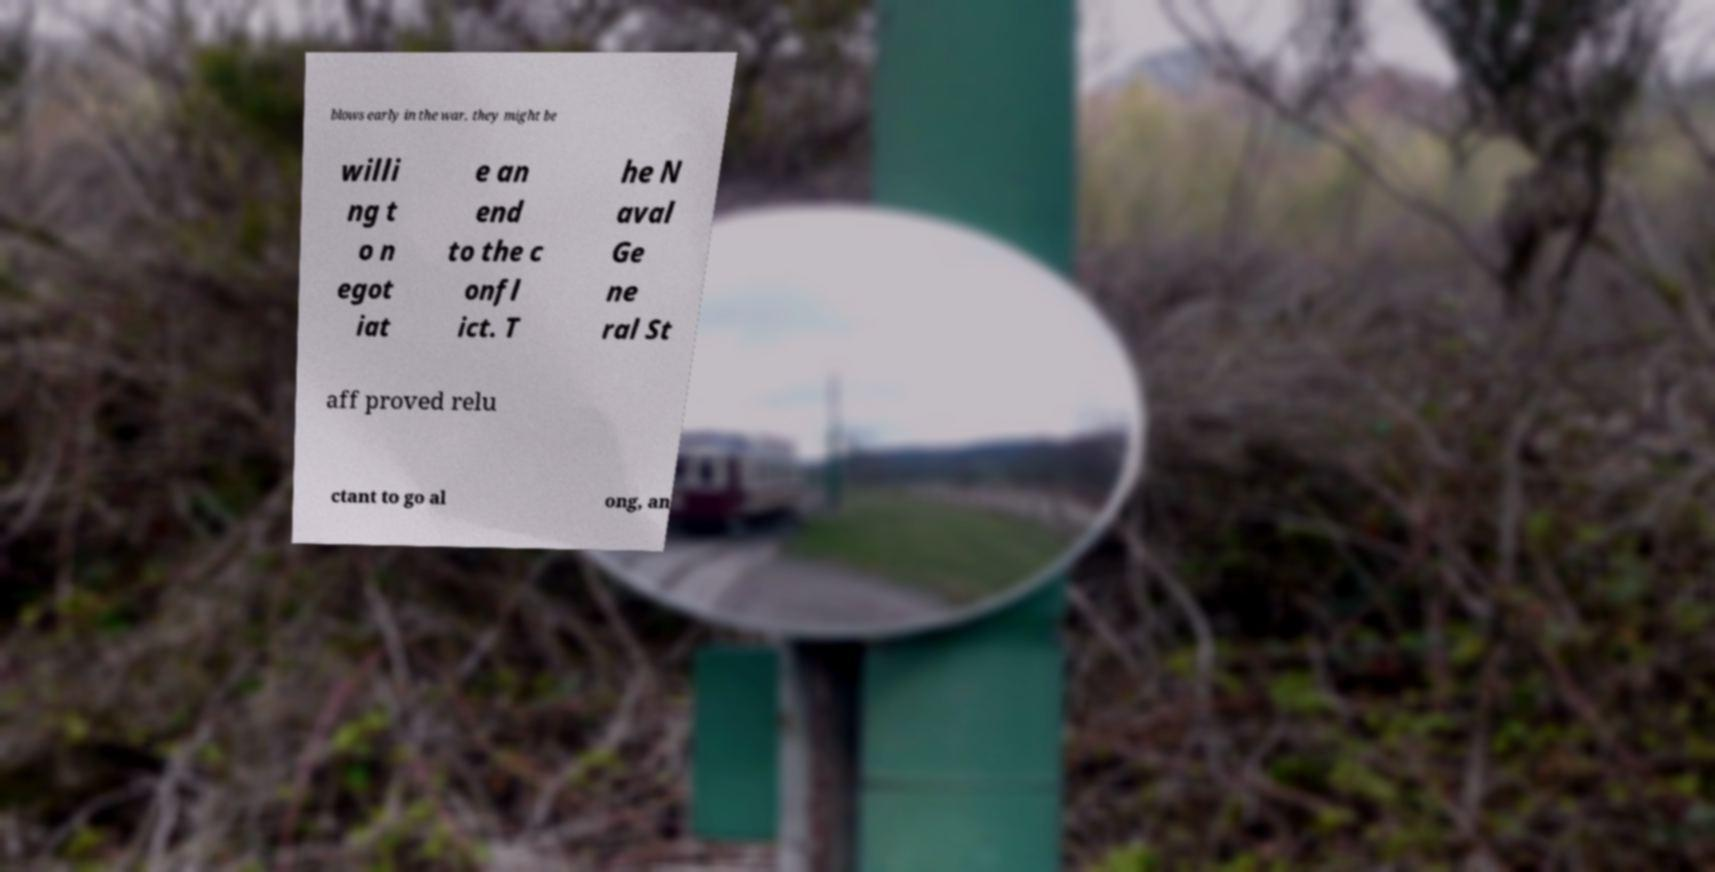Could you assist in decoding the text presented in this image and type it out clearly? blows early in the war, they might be willi ng t o n egot iat e an end to the c onfl ict. T he N aval Ge ne ral St aff proved relu ctant to go al ong, an 